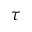<formula> <loc_0><loc_0><loc_500><loc_500>\tau</formula> 